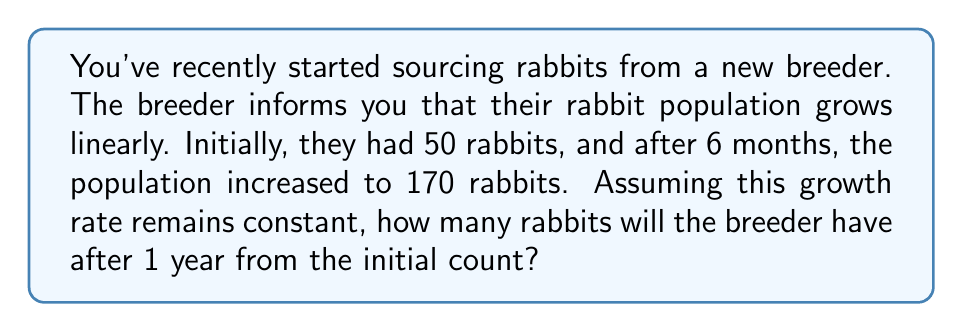Could you help me with this problem? Let's approach this step-by-step using a linear equation:

1) Let $y$ represent the number of rabbits and $x$ represent the number of months.

2) The linear equation has the form $y = mx + b$, where $m$ is the slope (growth rate) and $b$ is the y-intercept (initial population).

3) We know two points:
   $(0, 50)$ - initial population
   $(6, 170)$ - population after 6 months

4) We can calculate the slope (growth rate per month):

   $m = \frac{y_2 - y_1}{x_2 - x_1} = \frac{170 - 50}{6 - 0} = \frac{120}{6} = 20$

5) Now we have $m = 20$ and $b = 50$, so our equation is:

   $y = 20x + 50$

6) To find the population after 1 year (12 months), we substitute $x = 12$:

   $y = 20(12) + 50 = 240 + 50 = 290$

Therefore, after 1 year, the breeder will have 290 rabbits.
Answer: 290 rabbits 